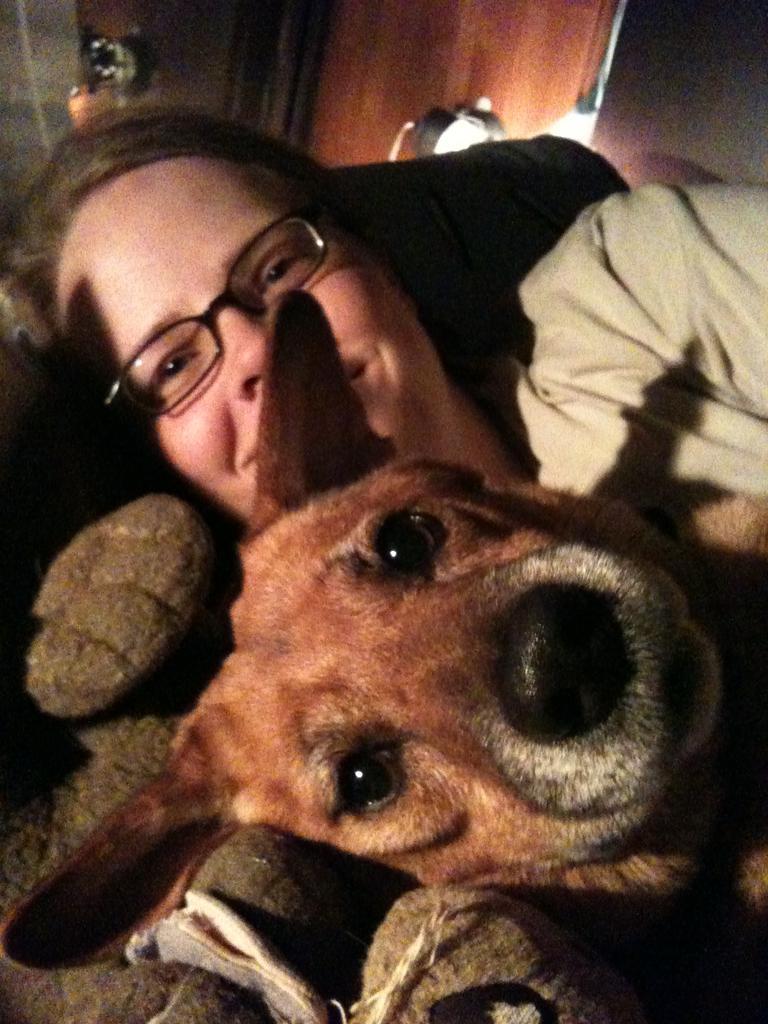Can you describe this image briefly? In this picture I can see a woman and a dog and I can see a woman wore spectacles and looks like a door on the back. 